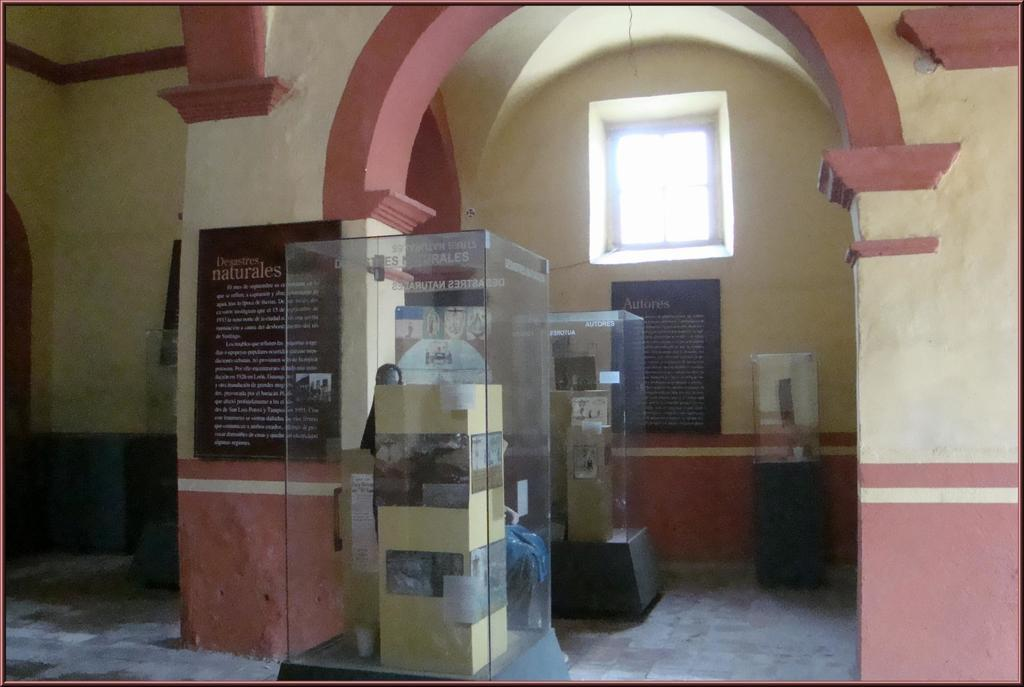What is attached to the small pillar in the image? There are posts attached to a small pillar in the image. How are the posts contained or displayed? The posts are inside glass objects. What can be seen on the wall in the image? There are posters attached to the wall in the image. Is there any source of natural light visible in the image? Yes, there is a window in the image. Can you see a scarecrow standing near the window in the image? No, there is no scarecrow present in the image. How many sheep are visible through the window in the image? There are no sheep visible through the window in the image. 